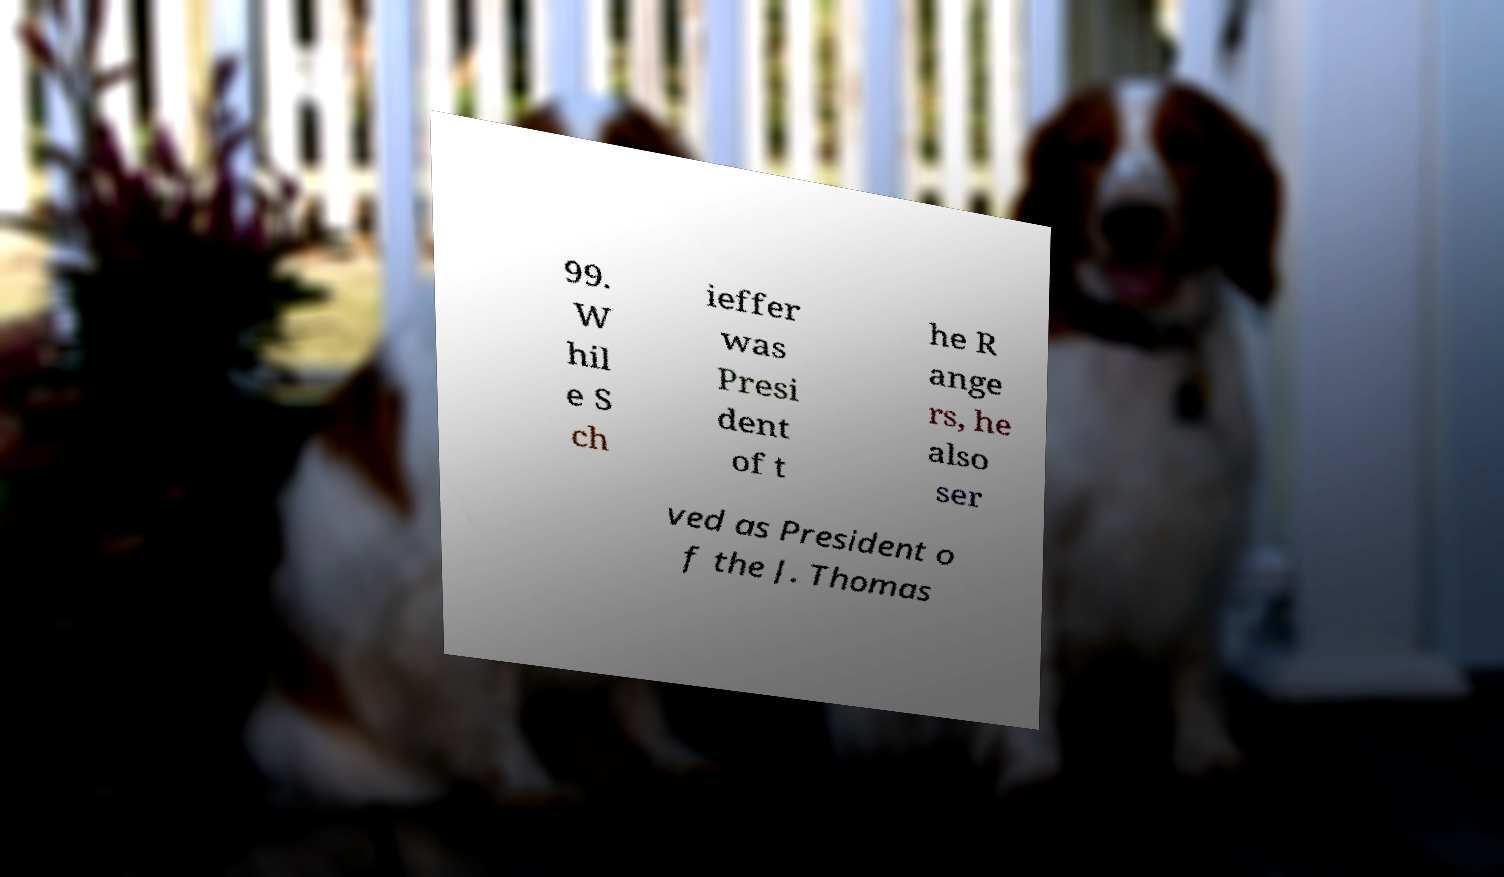Can you read and provide the text displayed in the image?This photo seems to have some interesting text. Can you extract and type it out for me? 99. W hil e S ch ieffer was Presi dent of t he R ange rs, he also ser ved as President o f the J. Thomas 